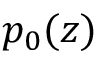<formula> <loc_0><loc_0><loc_500><loc_500>p _ { 0 } ( z )</formula> 